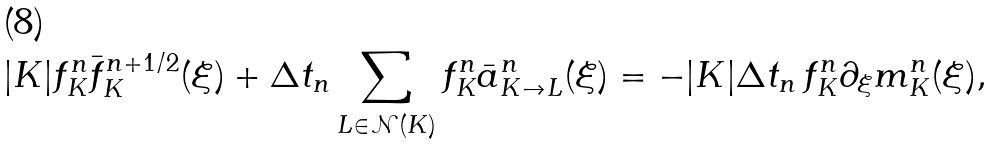<formula> <loc_0><loc_0><loc_500><loc_500>| K | f ^ { n } _ { K } \bar { f } ^ { n + 1 / 2 } _ { K } ( \xi ) + \Delta t _ { n } \sum _ { L \in \mathcal { N } ( K ) } f ^ { n } _ { K } \bar { a } _ { K \to L } ^ { n } ( \xi ) = - | K | \Delta t _ { n } \, f ^ { n } _ { K } \partial _ { \xi } m ^ { n } _ { K } ( \xi ) ,</formula> 